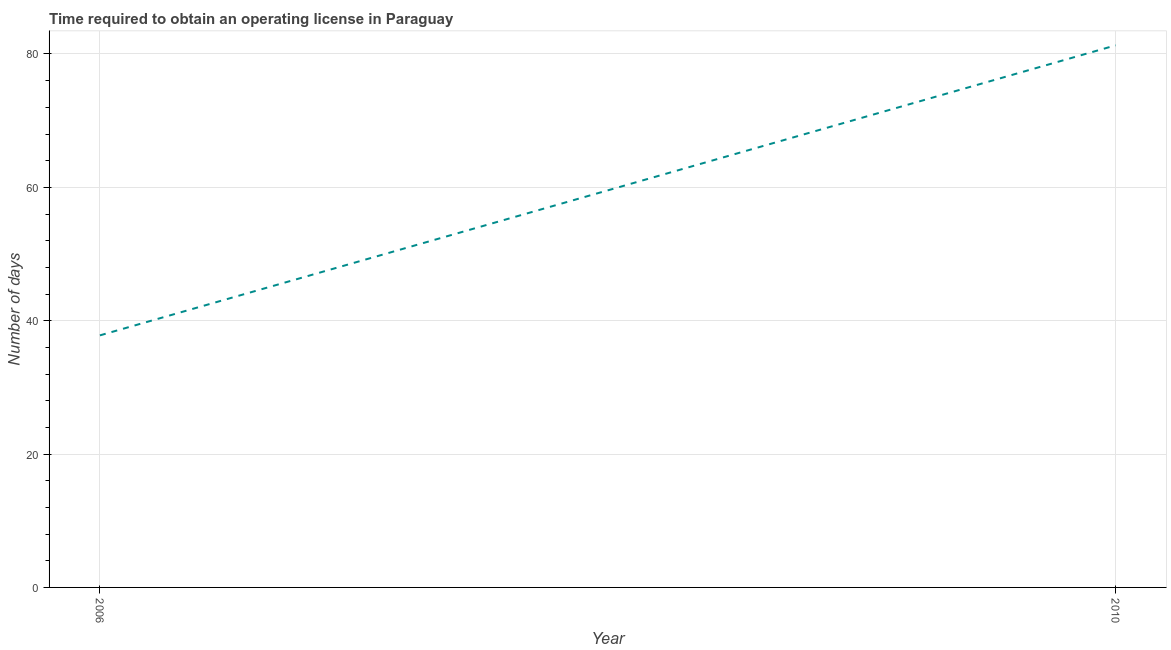What is the number of days to obtain operating license in 2006?
Give a very brief answer. 37.8. Across all years, what is the maximum number of days to obtain operating license?
Offer a very short reply. 81.3. Across all years, what is the minimum number of days to obtain operating license?
Provide a short and direct response. 37.8. What is the sum of the number of days to obtain operating license?
Your answer should be very brief. 119.1. What is the difference between the number of days to obtain operating license in 2006 and 2010?
Ensure brevity in your answer.  -43.5. What is the average number of days to obtain operating license per year?
Your answer should be compact. 59.55. What is the median number of days to obtain operating license?
Offer a very short reply. 59.55. In how many years, is the number of days to obtain operating license greater than 56 days?
Give a very brief answer. 1. What is the ratio of the number of days to obtain operating license in 2006 to that in 2010?
Ensure brevity in your answer.  0.46. Is the number of days to obtain operating license in 2006 less than that in 2010?
Give a very brief answer. Yes. In how many years, is the number of days to obtain operating license greater than the average number of days to obtain operating license taken over all years?
Give a very brief answer. 1. How many lines are there?
Keep it short and to the point. 1. How many years are there in the graph?
Give a very brief answer. 2. What is the difference between two consecutive major ticks on the Y-axis?
Your answer should be very brief. 20. Does the graph contain any zero values?
Offer a very short reply. No. Does the graph contain grids?
Provide a succinct answer. Yes. What is the title of the graph?
Keep it short and to the point. Time required to obtain an operating license in Paraguay. What is the label or title of the Y-axis?
Make the answer very short. Number of days. What is the Number of days in 2006?
Ensure brevity in your answer.  37.8. What is the Number of days in 2010?
Offer a very short reply. 81.3. What is the difference between the Number of days in 2006 and 2010?
Make the answer very short. -43.5. What is the ratio of the Number of days in 2006 to that in 2010?
Your answer should be very brief. 0.47. 